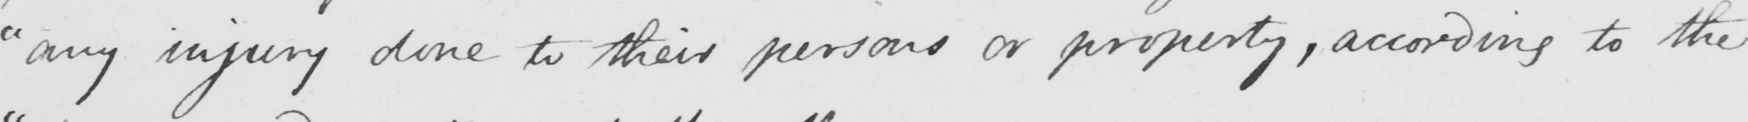Can you read and transcribe this handwriting? " any injury done to their persons or property , according to the 